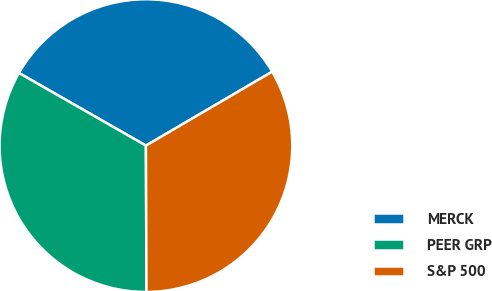<chart> <loc_0><loc_0><loc_500><loc_500><pie_chart><fcel>MERCK<fcel>PEER GRP<fcel>S&P 500<nl><fcel>33.3%<fcel>33.33%<fcel>33.37%<nl></chart> 